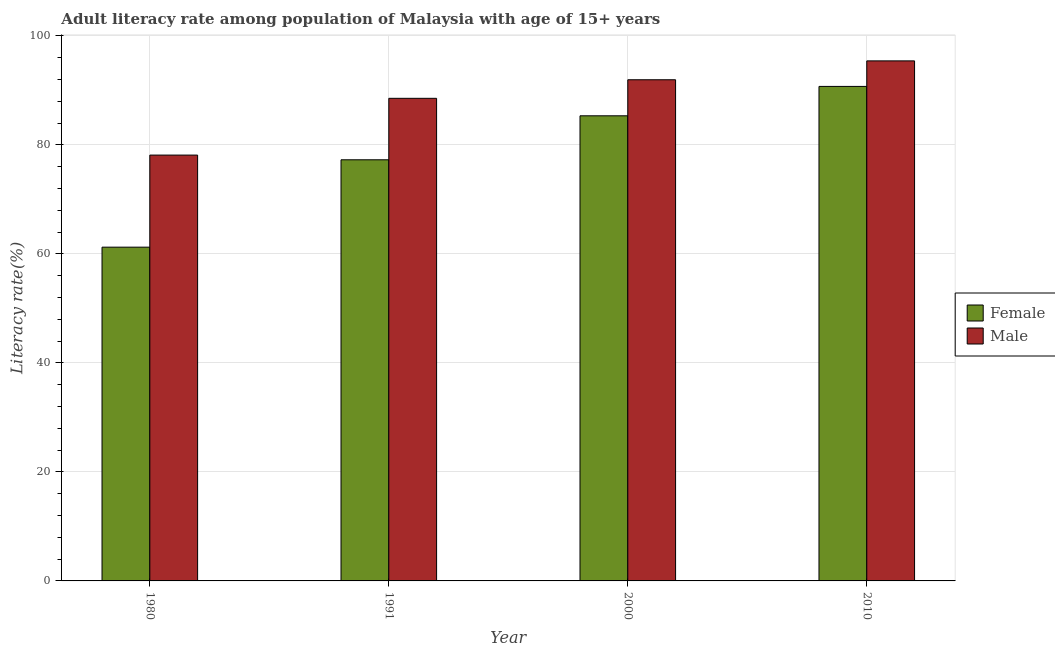How many different coloured bars are there?
Give a very brief answer. 2. Are the number of bars on each tick of the X-axis equal?
Offer a terse response. Yes. How many bars are there on the 3rd tick from the left?
Provide a succinct answer. 2. In how many cases, is the number of bars for a given year not equal to the number of legend labels?
Your answer should be compact. 0. What is the female adult literacy rate in 2000?
Give a very brief answer. 85.35. Across all years, what is the maximum male adult literacy rate?
Ensure brevity in your answer.  95.43. Across all years, what is the minimum male adult literacy rate?
Provide a short and direct response. 78.15. In which year was the male adult literacy rate maximum?
Provide a short and direct response. 2010. What is the total female adult literacy rate in the graph?
Give a very brief answer. 314.63. What is the difference between the male adult literacy rate in 1991 and that in 2000?
Your response must be concise. -3.41. What is the difference between the female adult literacy rate in 1991 and the male adult literacy rate in 2000?
Keep it short and to the point. -8.07. What is the average female adult literacy rate per year?
Offer a terse response. 78.66. In the year 1991, what is the difference between the male adult literacy rate and female adult literacy rate?
Your response must be concise. 0. In how many years, is the female adult literacy rate greater than 68 %?
Your response must be concise. 3. What is the ratio of the female adult literacy rate in 1980 to that in 1991?
Keep it short and to the point. 0.79. Is the female adult literacy rate in 2000 less than that in 2010?
Offer a very short reply. Yes. What is the difference between the highest and the second highest female adult literacy rate?
Keep it short and to the point. 5.39. What is the difference between the highest and the lowest female adult literacy rate?
Provide a succinct answer. 29.5. In how many years, is the male adult literacy rate greater than the average male adult literacy rate taken over all years?
Give a very brief answer. 3. What does the 1st bar from the left in 2000 represents?
Your response must be concise. Female. What does the 2nd bar from the right in 2010 represents?
Your response must be concise. Female. How many bars are there?
Make the answer very short. 8. What is the difference between two consecutive major ticks on the Y-axis?
Ensure brevity in your answer.  20. Does the graph contain any zero values?
Your answer should be very brief. No. How many legend labels are there?
Give a very brief answer. 2. What is the title of the graph?
Make the answer very short. Adult literacy rate among population of Malaysia with age of 15+ years. Does "Male labor force" appear as one of the legend labels in the graph?
Offer a very short reply. No. What is the label or title of the Y-axis?
Ensure brevity in your answer.  Literacy rate(%). What is the Literacy rate(%) in Female in 1980?
Your response must be concise. 61.25. What is the Literacy rate(%) in Male in 1980?
Your response must be concise. 78.15. What is the Literacy rate(%) of Female in 1991?
Give a very brief answer. 77.28. What is the Literacy rate(%) in Male in 1991?
Ensure brevity in your answer.  88.56. What is the Literacy rate(%) in Female in 2000?
Keep it short and to the point. 85.35. What is the Literacy rate(%) in Male in 2000?
Offer a terse response. 91.97. What is the Literacy rate(%) in Female in 2010?
Ensure brevity in your answer.  90.75. What is the Literacy rate(%) in Male in 2010?
Make the answer very short. 95.43. Across all years, what is the maximum Literacy rate(%) in Female?
Offer a very short reply. 90.75. Across all years, what is the maximum Literacy rate(%) in Male?
Give a very brief answer. 95.43. Across all years, what is the minimum Literacy rate(%) in Female?
Provide a short and direct response. 61.25. Across all years, what is the minimum Literacy rate(%) in Male?
Make the answer very short. 78.15. What is the total Literacy rate(%) of Female in the graph?
Ensure brevity in your answer.  314.63. What is the total Literacy rate(%) of Male in the graph?
Give a very brief answer. 354.11. What is the difference between the Literacy rate(%) in Female in 1980 and that in 1991?
Ensure brevity in your answer.  -16.03. What is the difference between the Literacy rate(%) in Male in 1980 and that in 1991?
Offer a terse response. -10.42. What is the difference between the Literacy rate(%) in Female in 1980 and that in 2000?
Your response must be concise. -24.11. What is the difference between the Literacy rate(%) in Male in 1980 and that in 2000?
Your response must be concise. -13.82. What is the difference between the Literacy rate(%) in Female in 1980 and that in 2010?
Your answer should be very brief. -29.5. What is the difference between the Literacy rate(%) in Male in 1980 and that in 2010?
Keep it short and to the point. -17.29. What is the difference between the Literacy rate(%) of Female in 1991 and that in 2000?
Provide a succinct answer. -8.07. What is the difference between the Literacy rate(%) of Male in 1991 and that in 2000?
Give a very brief answer. -3.41. What is the difference between the Literacy rate(%) of Female in 1991 and that in 2010?
Offer a terse response. -13.46. What is the difference between the Literacy rate(%) in Male in 1991 and that in 2010?
Provide a succinct answer. -6.87. What is the difference between the Literacy rate(%) of Female in 2000 and that in 2010?
Provide a succinct answer. -5.39. What is the difference between the Literacy rate(%) in Male in 2000 and that in 2010?
Your answer should be very brief. -3.46. What is the difference between the Literacy rate(%) of Female in 1980 and the Literacy rate(%) of Male in 1991?
Offer a very short reply. -27.31. What is the difference between the Literacy rate(%) in Female in 1980 and the Literacy rate(%) in Male in 2000?
Make the answer very short. -30.72. What is the difference between the Literacy rate(%) in Female in 1980 and the Literacy rate(%) in Male in 2010?
Offer a terse response. -34.19. What is the difference between the Literacy rate(%) in Female in 1991 and the Literacy rate(%) in Male in 2000?
Offer a terse response. -14.69. What is the difference between the Literacy rate(%) in Female in 1991 and the Literacy rate(%) in Male in 2010?
Provide a succinct answer. -18.15. What is the difference between the Literacy rate(%) of Female in 2000 and the Literacy rate(%) of Male in 2010?
Your answer should be compact. -10.08. What is the average Literacy rate(%) of Female per year?
Offer a terse response. 78.66. What is the average Literacy rate(%) of Male per year?
Give a very brief answer. 88.53. In the year 1980, what is the difference between the Literacy rate(%) of Female and Literacy rate(%) of Male?
Provide a short and direct response. -16.9. In the year 1991, what is the difference between the Literacy rate(%) of Female and Literacy rate(%) of Male?
Make the answer very short. -11.28. In the year 2000, what is the difference between the Literacy rate(%) in Female and Literacy rate(%) in Male?
Make the answer very short. -6.62. In the year 2010, what is the difference between the Literacy rate(%) in Female and Literacy rate(%) in Male?
Your answer should be very brief. -4.69. What is the ratio of the Literacy rate(%) in Female in 1980 to that in 1991?
Give a very brief answer. 0.79. What is the ratio of the Literacy rate(%) of Male in 1980 to that in 1991?
Offer a very short reply. 0.88. What is the ratio of the Literacy rate(%) of Female in 1980 to that in 2000?
Your response must be concise. 0.72. What is the ratio of the Literacy rate(%) in Male in 1980 to that in 2000?
Provide a short and direct response. 0.85. What is the ratio of the Literacy rate(%) in Female in 1980 to that in 2010?
Make the answer very short. 0.67. What is the ratio of the Literacy rate(%) of Male in 1980 to that in 2010?
Provide a short and direct response. 0.82. What is the ratio of the Literacy rate(%) of Female in 1991 to that in 2000?
Keep it short and to the point. 0.91. What is the ratio of the Literacy rate(%) in Male in 1991 to that in 2000?
Provide a short and direct response. 0.96. What is the ratio of the Literacy rate(%) in Female in 1991 to that in 2010?
Keep it short and to the point. 0.85. What is the ratio of the Literacy rate(%) in Male in 1991 to that in 2010?
Ensure brevity in your answer.  0.93. What is the ratio of the Literacy rate(%) of Female in 2000 to that in 2010?
Your answer should be very brief. 0.94. What is the ratio of the Literacy rate(%) in Male in 2000 to that in 2010?
Make the answer very short. 0.96. What is the difference between the highest and the second highest Literacy rate(%) of Female?
Provide a short and direct response. 5.39. What is the difference between the highest and the second highest Literacy rate(%) in Male?
Your answer should be compact. 3.46. What is the difference between the highest and the lowest Literacy rate(%) of Female?
Ensure brevity in your answer.  29.5. What is the difference between the highest and the lowest Literacy rate(%) in Male?
Keep it short and to the point. 17.29. 